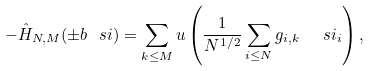<formula> <loc_0><loc_0><loc_500><loc_500>- \hat { H } _ { N , M } ( \pm b { \ s i } ) = \sum _ { k \leq M } u \left ( \frac { 1 } { N ^ { 1 / 2 } } \sum _ { i \leq N } g _ { i , k } \ \ s i _ { i } \right ) ,</formula> 